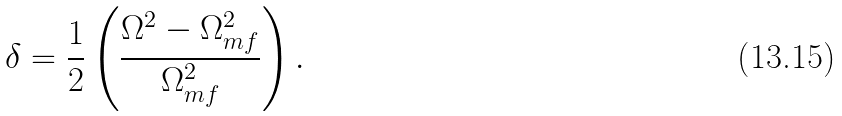Convert formula to latex. <formula><loc_0><loc_0><loc_500><loc_500>\delta = \frac { 1 } { 2 } \left ( \frac { \Omega ^ { 2 } - \Omega _ { m f } ^ { 2 } } { \Omega _ { m f } ^ { 2 } } \right ) .</formula> 